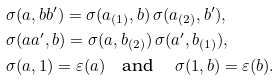Convert formula to latex. <formula><loc_0><loc_0><loc_500><loc_500>& \sigma ( a , b b ^ { \prime } ) = \sigma ( a _ { ( 1 ) } , b ) \, \sigma ( a _ { ( 2 ) } , b ^ { \prime } ) , \\ & \sigma ( a a ^ { \prime } , b ) = \sigma ( a , b _ { ( 2 ) } ) \, \sigma ( a ^ { \prime } , b _ { ( 1 ) } ) , \\ & \sigma ( a , 1 ) = \varepsilon ( a ) \text {\quad and \quad } \sigma ( 1 , b ) = \varepsilon ( b ) .</formula> 